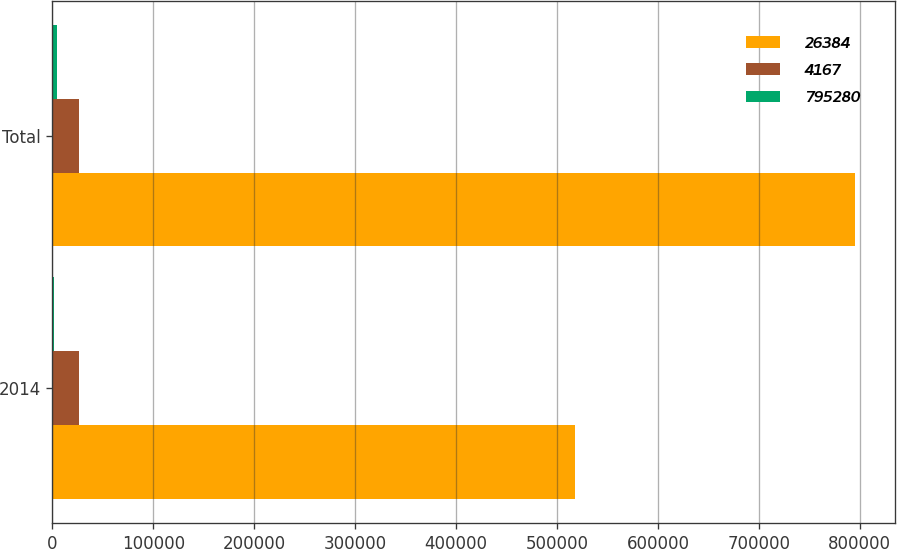Convert chart. <chart><loc_0><loc_0><loc_500><loc_500><stacked_bar_chart><ecel><fcel>2014<fcel>Total<nl><fcel>26384<fcel>517634<fcel>795280<nl><fcel>4167<fcel>26384<fcel>26384<nl><fcel>795280<fcel>1361<fcel>4167<nl></chart> 